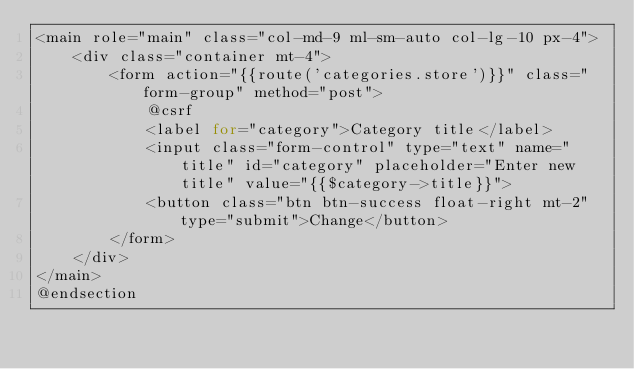Convert code to text. <code><loc_0><loc_0><loc_500><loc_500><_PHP_><main role="main" class="col-md-9 ml-sm-auto col-lg-10 px-4">
    <div class="container mt-4">
        <form action="{{route('categories.store')}}" class="form-group" method="post">
            @csrf
            <label for="category">Category title</label>
            <input class="form-control" type="text" name="title" id="category" placeholder="Enter new title" value="{{$category->title}}">
            <button class="btn btn-success float-right mt-2" type="submit">Change</button>
        </form>
    </div>
</main>
@endsection
</code> 